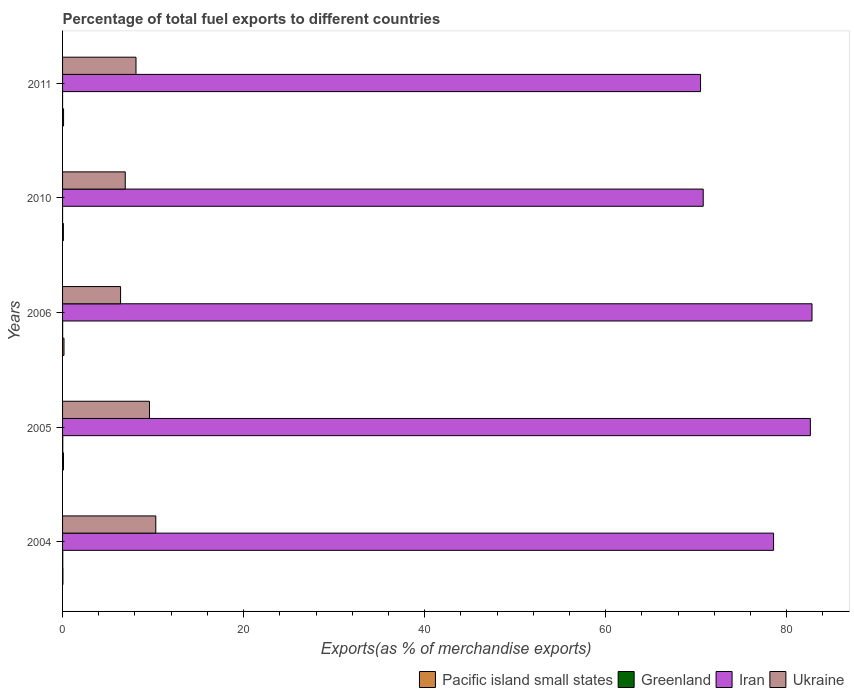How many different coloured bars are there?
Provide a short and direct response. 4. How many groups of bars are there?
Provide a succinct answer. 5. Are the number of bars per tick equal to the number of legend labels?
Offer a terse response. Yes. Are the number of bars on each tick of the Y-axis equal?
Your answer should be very brief. Yes. How many bars are there on the 1st tick from the top?
Offer a terse response. 4. How many bars are there on the 5th tick from the bottom?
Keep it short and to the point. 4. What is the percentage of exports to different countries in Greenland in 2005?
Keep it short and to the point. 0.02. Across all years, what is the maximum percentage of exports to different countries in Iran?
Keep it short and to the point. 82.79. Across all years, what is the minimum percentage of exports to different countries in Iran?
Offer a terse response. 70.48. In which year was the percentage of exports to different countries in Ukraine maximum?
Your answer should be compact. 2004. What is the total percentage of exports to different countries in Iran in the graph?
Provide a short and direct response. 385.2. What is the difference between the percentage of exports to different countries in Iran in 2006 and that in 2011?
Provide a short and direct response. 12.31. What is the difference between the percentage of exports to different countries in Pacific island small states in 2006 and the percentage of exports to different countries in Ukraine in 2005?
Make the answer very short. -9.44. What is the average percentage of exports to different countries in Pacific island small states per year?
Your answer should be compact. 0.1. In the year 2005, what is the difference between the percentage of exports to different countries in Pacific island small states and percentage of exports to different countries in Iran?
Keep it short and to the point. -82.51. What is the ratio of the percentage of exports to different countries in Iran in 2005 to that in 2010?
Ensure brevity in your answer.  1.17. Is the percentage of exports to different countries in Greenland in 2005 less than that in 2011?
Give a very brief answer. No. Is the difference between the percentage of exports to different countries in Pacific island small states in 2006 and 2011 greater than the difference between the percentage of exports to different countries in Iran in 2006 and 2011?
Make the answer very short. No. What is the difference between the highest and the second highest percentage of exports to different countries in Ukraine?
Give a very brief answer. 0.7. What is the difference between the highest and the lowest percentage of exports to different countries in Ukraine?
Your answer should be very brief. 3.89. In how many years, is the percentage of exports to different countries in Greenland greater than the average percentage of exports to different countries in Greenland taken over all years?
Offer a very short reply. 2. Is it the case that in every year, the sum of the percentage of exports to different countries in Ukraine and percentage of exports to different countries in Greenland is greater than the sum of percentage of exports to different countries in Pacific island small states and percentage of exports to different countries in Iran?
Offer a very short reply. No. What does the 3rd bar from the top in 2006 represents?
Provide a short and direct response. Greenland. What does the 2nd bar from the bottom in 2004 represents?
Keep it short and to the point. Greenland. Is it the case that in every year, the sum of the percentage of exports to different countries in Pacific island small states and percentage of exports to different countries in Iran is greater than the percentage of exports to different countries in Greenland?
Provide a short and direct response. Yes. How many bars are there?
Provide a short and direct response. 20. Are all the bars in the graph horizontal?
Ensure brevity in your answer.  Yes. How many years are there in the graph?
Provide a short and direct response. 5. Does the graph contain any zero values?
Your response must be concise. No. Does the graph contain grids?
Ensure brevity in your answer.  No. Where does the legend appear in the graph?
Provide a short and direct response. Bottom right. How many legend labels are there?
Provide a short and direct response. 4. What is the title of the graph?
Offer a terse response. Percentage of total fuel exports to different countries. What is the label or title of the X-axis?
Offer a very short reply. Exports(as % of merchandise exports). What is the label or title of the Y-axis?
Keep it short and to the point. Years. What is the Exports(as % of merchandise exports) in Pacific island small states in 2004?
Ensure brevity in your answer.  0.04. What is the Exports(as % of merchandise exports) of Greenland in 2004?
Offer a very short reply. 0.02. What is the Exports(as % of merchandise exports) of Iran in 2004?
Give a very brief answer. 78.55. What is the Exports(as % of merchandise exports) of Ukraine in 2004?
Provide a short and direct response. 10.3. What is the Exports(as % of merchandise exports) in Pacific island small states in 2005?
Offer a terse response. 0.1. What is the Exports(as % of merchandise exports) of Greenland in 2005?
Your response must be concise. 0.02. What is the Exports(as % of merchandise exports) of Iran in 2005?
Your answer should be compact. 82.61. What is the Exports(as % of merchandise exports) of Ukraine in 2005?
Provide a succinct answer. 9.6. What is the Exports(as % of merchandise exports) in Pacific island small states in 2006?
Provide a succinct answer. 0.16. What is the Exports(as % of merchandise exports) in Greenland in 2006?
Your response must be concise. 0.01. What is the Exports(as % of merchandise exports) of Iran in 2006?
Provide a succinct answer. 82.79. What is the Exports(as % of merchandise exports) in Ukraine in 2006?
Offer a very short reply. 6.41. What is the Exports(as % of merchandise exports) of Pacific island small states in 2010?
Your response must be concise. 0.09. What is the Exports(as % of merchandise exports) in Greenland in 2010?
Provide a succinct answer. 0. What is the Exports(as % of merchandise exports) in Iran in 2010?
Your answer should be compact. 70.77. What is the Exports(as % of merchandise exports) in Ukraine in 2010?
Give a very brief answer. 6.93. What is the Exports(as % of merchandise exports) in Pacific island small states in 2011?
Your response must be concise. 0.11. What is the Exports(as % of merchandise exports) of Greenland in 2011?
Your response must be concise. 0. What is the Exports(as % of merchandise exports) of Iran in 2011?
Give a very brief answer. 70.48. What is the Exports(as % of merchandise exports) in Ukraine in 2011?
Your answer should be compact. 8.11. Across all years, what is the maximum Exports(as % of merchandise exports) of Pacific island small states?
Give a very brief answer. 0.16. Across all years, what is the maximum Exports(as % of merchandise exports) in Greenland?
Offer a very short reply. 0.02. Across all years, what is the maximum Exports(as % of merchandise exports) of Iran?
Give a very brief answer. 82.79. Across all years, what is the maximum Exports(as % of merchandise exports) of Ukraine?
Your answer should be very brief. 10.3. Across all years, what is the minimum Exports(as % of merchandise exports) in Pacific island small states?
Your answer should be compact. 0.04. Across all years, what is the minimum Exports(as % of merchandise exports) in Greenland?
Your response must be concise. 0. Across all years, what is the minimum Exports(as % of merchandise exports) of Iran?
Offer a terse response. 70.48. Across all years, what is the minimum Exports(as % of merchandise exports) in Ukraine?
Your answer should be very brief. 6.41. What is the total Exports(as % of merchandise exports) of Pacific island small states in the graph?
Offer a very short reply. 0.5. What is the total Exports(as % of merchandise exports) of Greenland in the graph?
Your answer should be very brief. 0.05. What is the total Exports(as % of merchandise exports) in Iran in the graph?
Provide a short and direct response. 385.2. What is the total Exports(as % of merchandise exports) in Ukraine in the graph?
Provide a succinct answer. 41.35. What is the difference between the Exports(as % of merchandise exports) in Pacific island small states in 2004 and that in 2005?
Make the answer very short. -0.06. What is the difference between the Exports(as % of merchandise exports) in Iran in 2004 and that in 2005?
Provide a short and direct response. -4.06. What is the difference between the Exports(as % of merchandise exports) in Ukraine in 2004 and that in 2005?
Give a very brief answer. 0.7. What is the difference between the Exports(as % of merchandise exports) in Pacific island small states in 2004 and that in 2006?
Make the answer very short. -0.12. What is the difference between the Exports(as % of merchandise exports) in Greenland in 2004 and that in 2006?
Ensure brevity in your answer.  0.01. What is the difference between the Exports(as % of merchandise exports) in Iran in 2004 and that in 2006?
Your answer should be very brief. -4.25. What is the difference between the Exports(as % of merchandise exports) of Ukraine in 2004 and that in 2006?
Offer a terse response. 3.89. What is the difference between the Exports(as % of merchandise exports) of Pacific island small states in 2004 and that in 2010?
Keep it short and to the point. -0.05. What is the difference between the Exports(as % of merchandise exports) in Greenland in 2004 and that in 2010?
Keep it short and to the point. 0.02. What is the difference between the Exports(as % of merchandise exports) in Iran in 2004 and that in 2010?
Provide a short and direct response. 7.77. What is the difference between the Exports(as % of merchandise exports) in Ukraine in 2004 and that in 2010?
Ensure brevity in your answer.  3.37. What is the difference between the Exports(as % of merchandise exports) in Pacific island small states in 2004 and that in 2011?
Your answer should be compact. -0.07. What is the difference between the Exports(as % of merchandise exports) in Greenland in 2004 and that in 2011?
Your answer should be compact. 0.02. What is the difference between the Exports(as % of merchandise exports) of Iran in 2004 and that in 2011?
Give a very brief answer. 8.07. What is the difference between the Exports(as % of merchandise exports) of Ukraine in 2004 and that in 2011?
Offer a terse response. 2.19. What is the difference between the Exports(as % of merchandise exports) of Pacific island small states in 2005 and that in 2006?
Provide a succinct answer. -0.05. What is the difference between the Exports(as % of merchandise exports) of Greenland in 2005 and that in 2006?
Give a very brief answer. 0.01. What is the difference between the Exports(as % of merchandise exports) in Iran in 2005 and that in 2006?
Ensure brevity in your answer.  -0.18. What is the difference between the Exports(as % of merchandise exports) in Ukraine in 2005 and that in 2006?
Offer a terse response. 3.19. What is the difference between the Exports(as % of merchandise exports) in Pacific island small states in 2005 and that in 2010?
Provide a short and direct response. 0.01. What is the difference between the Exports(as % of merchandise exports) of Greenland in 2005 and that in 2010?
Your answer should be compact. 0.02. What is the difference between the Exports(as % of merchandise exports) in Iran in 2005 and that in 2010?
Offer a very short reply. 11.84. What is the difference between the Exports(as % of merchandise exports) of Ukraine in 2005 and that in 2010?
Provide a succinct answer. 2.67. What is the difference between the Exports(as % of merchandise exports) in Pacific island small states in 2005 and that in 2011?
Ensure brevity in your answer.  -0.01. What is the difference between the Exports(as % of merchandise exports) in Greenland in 2005 and that in 2011?
Make the answer very short. 0.02. What is the difference between the Exports(as % of merchandise exports) in Iran in 2005 and that in 2011?
Ensure brevity in your answer.  12.13. What is the difference between the Exports(as % of merchandise exports) in Ukraine in 2005 and that in 2011?
Keep it short and to the point. 1.49. What is the difference between the Exports(as % of merchandise exports) of Pacific island small states in 2006 and that in 2010?
Provide a short and direct response. 0.07. What is the difference between the Exports(as % of merchandise exports) of Greenland in 2006 and that in 2010?
Provide a succinct answer. 0.01. What is the difference between the Exports(as % of merchandise exports) in Iran in 2006 and that in 2010?
Keep it short and to the point. 12.02. What is the difference between the Exports(as % of merchandise exports) in Ukraine in 2006 and that in 2010?
Your response must be concise. -0.52. What is the difference between the Exports(as % of merchandise exports) of Pacific island small states in 2006 and that in 2011?
Your response must be concise. 0.05. What is the difference between the Exports(as % of merchandise exports) in Greenland in 2006 and that in 2011?
Give a very brief answer. 0.01. What is the difference between the Exports(as % of merchandise exports) in Iran in 2006 and that in 2011?
Offer a terse response. 12.31. What is the difference between the Exports(as % of merchandise exports) in Ukraine in 2006 and that in 2011?
Keep it short and to the point. -1.7. What is the difference between the Exports(as % of merchandise exports) in Pacific island small states in 2010 and that in 2011?
Provide a short and direct response. -0.02. What is the difference between the Exports(as % of merchandise exports) in Greenland in 2010 and that in 2011?
Your response must be concise. 0. What is the difference between the Exports(as % of merchandise exports) of Iran in 2010 and that in 2011?
Make the answer very short. 0.3. What is the difference between the Exports(as % of merchandise exports) in Ukraine in 2010 and that in 2011?
Ensure brevity in your answer.  -1.19. What is the difference between the Exports(as % of merchandise exports) of Pacific island small states in 2004 and the Exports(as % of merchandise exports) of Greenland in 2005?
Your response must be concise. 0.02. What is the difference between the Exports(as % of merchandise exports) of Pacific island small states in 2004 and the Exports(as % of merchandise exports) of Iran in 2005?
Make the answer very short. -82.57. What is the difference between the Exports(as % of merchandise exports) in Pacific island small states in 2004 and the Exports(as % of merchandise exports) in Ukraine in 2005?
Ensure brevity in your answer.  -9.56. What is the difference between the Exports(as % of merchandise exports) of Greenland in 2004 and the Exports(as % of merchandise exports) of Iran in 2005?
Keep it short and to the point. -82.59. What is the difference between the Exports(as % of merchandise exports) of Greenland in 2004 and the Exports(as % of merchandise exports) of Ukraine in 2005?
Provide a short and direct response. -9.58. What is the difference between the Exports(as % of merchandise exports) of Iran in 2004 and the Exports(as % of merchandise exports) of Ukraine in 2005?
Keep it short and to the point. 68.95. What is the difference between the Exports(as % of merchandise exports) in Pacific island small states in 2004 and the Exports(as % of merchandise exports) in Greenland in 2006?
Ensure brevity in your answer.  0.03. What is the difference between the Exports(as % of merchandise exports) of Pacific island small states in 2004 and the Exports(as % of merchandise exports) of Iran in 2006?
Your response must be concise. -82.75. What is the difference between the Exports(as % of merchandise exports) in Pacific island small states in 2004 and the Exports(as % of merchandise exports) in Ukraine in 2006?
Your response must be concise. -6.37. What is the difference between the Exports(as % of merchandise exports) of Greenland in 2004 and the Exports(as % of merchandise exports) of Iran in 2006?
Provide a succinct answer. -82.77. What is the difference between the Exports(as % of merchandise exports) in Greenland in 2004 and the Exports(as % of merchandise exports) in Ukraine in 2006?
Make the answer very short. -6.39. What is the difference between the Exports(as % of merchandise exports) of Iran in 2004 and the Exports(as % of merchandise exports) of Ukraine in 2006?
Your response must be concise. 72.14. What is the difference between the Exports(as % of merchandise exports) in Pacific island small states in 2004 and the Exports(as % of merchandise exports) in Greenland in 2010?
Offer a terse response. 0.04. What is the difference between the Exports(as % of merchandise exports) of Pacific island small states in 2004 and the Exports(as % of merchandise exports) of Iran in 2010?
Ensure brevity in your answer.  -70.74. What is the difference between the Exports(as % of merchandise exports) of Pacific island small states in 2004 and the Exports(as % of merchandise exports) of Ukraine in 2010?
Provide a short and direct response. -6.89. What is the difference between the Exports(as % of merchandise exports) of Greenland in 2004 and the Exports(as % of merchandise exports) of Iran in 2010?
Ensure brevity in your answer.  -70.75. What is the difference between the Exports(as % of merchandise exports) in Greenland in 2004 and the Exports(as % of merchandise exports) in Ukraine in 2010?
Your response must be concise. -6.9. What is the difference between the Exports(as % of merchandise exports) in Iran in 2004 and the Exports(as % of merchandise exports) in Ukraine in 2010?
Ensure brevity in your answer.  71.62. What is the difference between the Exports(as % of merchandise exports) of Pacific island small states in 2004 and the Exports(as % of merchandise exports) of Greenland in 2011?
Offer a terse response. 0.04. What is the difference between the Exports(as % of merchandise exports) of Pacific island small states in 2004 and the Exports(as % of merchandise exports) of Iran in 2011?
Offer a terse response. -70.44. What is the difference between the Exports(as % of merchandise exports) in Pacific island small states in 2004 and the Exports(as % of merchandise exports) in Ukraine in 2011?
Make the answer very short. -8.07. What is the difference between the Exports(as % of merchandise exports) of Greenland in 2004 and the Exports(as % of merchandise exports) of Iran in 2011?
Make the answer very short. -70.46. What is the difference between the Exports(as % of merchandise exports) of Greenland in 2004 and the Exports(as % of merchandise exports) of Ukraine in 2011?
Ensure brevity in your answer.  -8.09. What is the difference between the Exports(as % of merchandise exports) in Iran in 2004 and the Exports(as % of merchandise exports) in Ukraine in 2011?
Offer a terse response. 70.43. What is the difference between the Exports(as % of merchandise exports) in Pacific island small states in 2005 and the Exports(as % of merchandise exports) in Greenland in 2006?
Offer a terse response. 0.09. What is the difference between the Exports(as % of merchandise exports) of Pacific island small states in 2005 and the Exports(as % of merchandise exports) of Iran in 2006?
Provide a short and direct response. -82.69. What is the difference between the Exports(as % of merchandise exports) of Pacific island small states in 2005 and the Exports(as % of merchandise exports) of Ukraine in 2006?
Offer a terse response. -6.31. What is the difference between the Exports(as % of merchandise exports) of Greenland in 2005 and the Exports(as % of merchandise exports) of Iran in 2006?
Make the answer very short. -82.77. What is the difference between the Exports(as % of merchandise exports) of Greenland in 2005 and the Exports(as % of merchandise exports) of Ukraine in 2006?
Your response must be concise. -6.39. What is the difference between the Exports(as % of merchandise exports) of Iran in 2005 and the Exports(as % of merchandise exports) of Ukraine in 2006?
Give a very brief answer. 76.2. What is the difference between the Exports(as % of merchandise exports) of Pacific island small states in 2005 and the Exports(as % of merchandise exports) of Greenland in 2010?
Keep it short and to the point. 0.1. What is the difference between the Exports(as % of merchandise exports) in Pacific island small states in 2005 and the Exports(as % of merchandise exports) in Iran in 2010?
Provide a short and direct response. -70.67. What is the difference between the Exports(as % of merchandise exports) of Pacific island small states in 2005 and the Exports(as % of merchandise exports) of Ukraine in 2010?
Your response must be concise. -6.82. What is the difference between the Exports(as % of merchandise exports) in Greenland in 2005 and the Exports(as % of merchandise exports) in Iran in 2010?
Make the answer very short. -70.75. What is the difference between the Exports(as % of merchandise exports) of Greenland in 2005 and the Exports(as % of merchandise exports) of Ukraine in 2010?
Your response must be concise. -6.9. What is the difference between the Exports(as % of merchandise exports) in Iran in 2005 and the Exports(as % of merchandise exports) in Ukraine in 2010?
Your answer should be compact. 75.69. What is the difference between the Exports(as % of merchandise exports) of Pacific island small states in 2005 and the Exports(as % of merchandise exports) of Greenland in 2011?
Ensure brevity in your answer.  0.1. What is the difference between the Exports(as % of merchandise exports) of Pacific island small states in 2005 and the Exports(as % of merchandise exports) of Iran in 2011?
Offer a terse response. -70.38. What is the difference between the Exports(as % of merchandise exports) of Pacific island small states in 2005 and the Exports(as % of merchandise exports) of Ukraine in 2011?
Give a very brief answer. -8.01. What is the difference between the Exports(as % of merchandise exports) in Greenland in 2005 and the Exports(as % of merchandise exports) in Iran in 2011?
Offer a terse response. -70.46. What is the difference between the Exports(as % of merchandise exports) of Greenland in 2005 and the Exports(as % of merchandise exports) of Ukraine in 2011?
Make the answer very short. -8.09. What is the difference between the Exports(as % of merchandise exports) of Iran in 2005 and the Exports(as % of merchandise exports) of Ukraine in 2011?
Keep it short and to the point. 74.5. What is the difference between the Exports(as % of merchandise exports) in Pacific island small states in 2006 and the Exports(as % of merchandise exports) in Greenland in 2010?
Make the answer very short. 0.16. What is the difference between the Exports(as % of merchandise exports) in Pacific island small states in 2006 and the Exports(as % of merchandise exports) in Iran in 2010?
Your response must be concise. -70.62. What is the difference between the Exports(as % of merchandise exports) in Pacific island small states in 2006 and the Exports(as % of merchandise exports) in Ukraine in 2010?
Provide a succinct answer. -6.77. What is the difference between the Exports(as % of merchandise exports) of Greenland in 2006 and the Exports(as % of merchandise exports) of Iran in 2010?
Provide a succinct answer. -70.77. What is the difference between the Exports(as % of merchandise exports) in Greenland in 2006 and the Exports(as % of merchandise exports) in Ukraine in 2010?
Keep it short and to the point. -6.92. What is the difference between the Exports(as % of merchandise exports) of Iran in 2006 and the Exports(as % of merchandise exports) of Ukraine in 2010?
Ensure brevity in your answer.  75.87. What is the difference between the Exports(as % of merchandise exports) in Pacific island small states in 2006 and the Exports(as % of merchandise exports) in Greenland in 2011?
Provide a succinct answer. 0.16. What is the difference between the Exports(as % of merchandise exports) in Pacific island small states in 2006 and the Exports(as % of merchandise exports) in Iran in 2011?
Provide a short and direct response. -70.32. What is the difference between the Exports(as % of merchandise exports) in Pacific island small states in 2006 and the Exports(as % of merchandise exports) in Ukraine in 2011?
Offer a very short reply. -7.96. What is the difference between the Exports(as % of merchandise exports) in Greenland in 2006 and the Exports(as % of merchandise exports) in Iran in 2011?
Ensure brevity in your answer.  -70.47. What is the difference between the Exports(as % of merchandise exports) of Greenland in 2006 and the Exports(as % of merchandise exports) of Ukraine in 2011?
Offer a terse response. -8.1. What is the difference between the Exports(as % of merchandise exports) of Iran in 2006 and the Exports(as % of merchandise exports) of Ukraine in 2011?
Keep it short and to the point. 74.68. What is the difference between the Exports(as % of merchandise exports) of Pacific island small states in 2010 and the Exports(as % of merchandise exports) of Greenland in 2011?
Offer a very short reply. 0.09. What is the difference between the Exports(as % of merchandise exports) in Pacific island small states in 2010 and the Exports(as % of merchandise exports) in Iran in 2011?
Make the answer very short. -70.39. What is the difference between the Exports(as % of merchandise exports) in Pacific island small states in 2010 and the Exports(as % of merchandise exports) in Ukraine in 2011?
Your answer should be very brief. -8.02. What is the difference between the Exports(as % of merchandise exports) in Greenland in 2010 and the Exports(as % of merchandise exports) in Iran in 2011?
Give a very brief answer. -70.48. What is the difference between the Exports(as % of merchandise exports) of Greenland in 2010 and the Exports(as % of merchandise exports) of Ukraine in 2011?
Make the answer very short. -8.11. What is the difference between the Exports(as % of merchandise exports) of Iran in 2010 and the Exports(as % of merchandise exports) of Ukraine in 2011?
Ensure brevity in your answer.  62.66. What is the average Exports(as % of merchandise exports) of Pacific island small states per year?
Ensure brevity in your answer.  0.1. What is the average Exports(as % of merchandise exports) in Greenland per year?
Make the answer very short. 0.01. What is the average Exports(as % of merchandise exports) of Iran per year?
Offer a very short reply. 77.04. What is the average Exports(as % of merchandise exports) of Ukraine per year?
Ensure brevity in your answer.  8.27. In the year 2004, what is the difference between the Exports(as % of merchandise exports) of Pacific island small states and Exports(as % of merchandise exports) of Greenland?
Offer a terse response. 0.02. In the year 2004, what is the difference between the Exports(as % of merchandise exports) of Pacific island small states and Exports(as % of merchandise exports) of Iran?
Give a very brief answer. -78.51. In the year 2004, what is the difference between the Exports(as % of merchandise exports) in Pacific island small states and Exports(as % of merchandise exports) in Ukraine?
Make the answer very short. -10.26. In the year 2004, what is the difference between the Exports(as % of merchandise exports) of Greenland and Exports(as % of merchandise exports) of Iran?
Your answer should be compact. -78.52. In the year 2004, what is the difference between the Exports(as % of merchandise exports) of Greenland and Exports(as % of merchandise exports) of Ukraine?
Offer a terse response. -10.28. In the year 2004, what is the difference between the Exports(as % of merchandise exports) of Iran and Exports(as % of merchandise exports) of Ukraine?
Give a very brief answer. 68.25. In the year 2005, what is the difference between the Exports(as % of merchandise exports) in Pacific island small states and Exports(as % of merchandise exports) in Greenland?
Provide a succinct answer. 0.08. In the year 2005, what is the difference between the Exports(as % of merchandise exports) in Pacific island small states and Exports(as % of merchandise exports) in Iran?
Ensure brevity in your answer.  -82.51. In the year 2005, what is the difference between the Exports(as % of merchandise exports) of Pacific island small states and Exports(as % of merchandise exports) of Ukraine?
Keep it short and to the point. -9.5. In the year 2005, what is the difference between the Exports(as % of merchandise exports) in Greenland and Exports(as % of merchandise exports) in Iran?
Provide a succinct answer. -82.59. In the year 2005, what is the difference between the Exports(as % of merchandise exports) in Greenland and Exports(as % of merchandise exports) in Ukraine?
Provide a succinct answer. -9.58. In the year 2005, what is the difference between the Exports(as % of merchandise exports) of Iran and Exports(as % of merchandise exports) of Ukraine?
Your response must be concise. 73.01. In the year 2006, what is the difference between the Exports(as % of merchandise exports) of Pacific island small states and Exports(as % of merchandise exports) of Greenland?
Keep it short and to the point. 0.15. In the year 2006, what is the difference between the Exports(as % of merchandise exports) of Pacific island small states and Exports(as % of merchandise exports) of Iran?
Your answer should be very brief. -82.64. In the year 2006, what is the difference between the Exports(as % of merchandise exports) in Pacific island small states and Exports(as % of merchandise exports) in Ukraine?
Ensure brevity in your answer.  -6.25. In the year 2006, what is the difference between the Exports(as % of merchandise exports) in Greenland and Exports(as % of merchandise exports) in Iran?
Provide a succinct answer. -82.79. In the year 2006, what is the difference between the Exports(as % of merchandise exports) in Greenland and Exports(as % of merchandise exports) in Ukraine?
Ensure brevity in your answer.  -6.4. In the year 2006, what is the difference between the Exports(as % of merchandise exports) of Iran and Exports(as % of merchandise exports) of Ukraine?
Offer a very short reply. 76.38. In the year 2010, what is the difference between the Exports(as % of merchandise exports) of Pacific island small states and Exports(as % of merchandise exports) of Greenland?
Offer a very short reply. 0.09. In the year 2010, what is the difference between the Exports(as % of merchandise exports) in Pacific island small states and Exports(as % of merchandise exports) in Iran?
Keep it short and to the point. -70.68. In the year 2010, what is the difference between the Exports(as % of merchandise exports) in Pacific island small states and Exports(as % of merchandise exports) in Ukraine?
Offer a terse response. -6.84. In the year 2010, what is the difference between the Exports(as % of merchandise exports) of Greenland and Exports(as % of merchandise exports) of Iran?
Provide a succinct answer. -70.77. In the year 2010, what is the difference between the Exports(as % of merchandise exports) of Greenland and Exports(as % of merchandise exports) of Ukraine?
Ensure brevity in your answer.  -6.92. In the year 2010, what is the difference between the Exports(as % of merchandise exports) in Iran and Exports(as % of merchandise exports) in Ukraine?
Make the answer very short. 63.85. In the year 2011, what is the difference between the Exports(as % of merchandise exports) of Pacific island small states and Exports(as % of merchandise exports) of Greenland?
Your answer should be very brief. 0.11. In the year 2011, what is the difference between the Exports(as % of merchandise exports) of Pacific island small states and Exports(as % of merchandise exports) of Iran?
Ensure brevity in your answer.  -70.37. In the year 2011, what is the difference between the Exports(as % of merchandise exports) of Pacific island small states and Exports(as % of merchandise exports) of Ukraine?
Make the answer very short. -8. In the year 2011, what is the difference between the Exports(as % of merchandise exports) of Greenland and Exports(as % of merchandise exports) of Iran?
Offer a terse response. -70.48. In the year 2011, what is the difference between the Exports(as % of merchandise exports) of Greenland and Exports(as % of merchandise exports) of Ukraine?
Provide a succinct answer. -8.11. In the year 2011, what is the difference between the Exports(as % of merchandise exports) of Iran and Exports(as % of merchandise exports) of Ukraine?
Give a very brief answer. 62.37. What is the ratio of the Exports(as % of merchandise exports) of Pacific island small states in 2004 to that in 2005?
Keep it short and to the point. 0.39. What is the ratio of the Exports(as % of merchandise exports) in Greenland in 2004 to that in 2005?
Give a very brief answer. 1.02. What is the ratio of the Exports(as % of merchandise exports) of Iran in 2004 to that in 2005?
Make the answer very short. 0.95. What is the ratio of the Exports(as % of merchandise exports) in Ukraine in 2004 to that in 2005?
Offer a terse response. 1.07. What is the ratio of the Exports(as % of merchandise exports) in Pacific island small states in 2004 to that in 2006?
Your response must be concise. 0.25. What is the ratio of the Exports(as % of merchandise exports) of Greenland in 2004 to that in 2006?
Provide a succinct answer. 2.93. What is the ratio of the Exports(as % of merchandise exports) in Iran in 2004 to that in 2006?
Offer a terse response. 0.95. What is the ratio of the Exports(as % of merchandise exports) in Ukraine in 2004 to that in 2006?
Offer a terse response. 1.61. What is the ratio of the Exports(as % of merchandise exports) in Pacific island small states in 2004 to that in 2010?
Keep it short and to the point. 0.44. What is the ratio of the Exports(as % of merchandise exports) in Greenland in 2004 to that in 2010?
Your response must be concise. 48.47. What is the ratio of the Exports(as % of merchandise exports) in Iran in 2004 to that in 2010?
Provide a succinct answer. 1.11. What is the ratio of the Exports(as % of merchandise exports) of Ukraine in 2004 to that in 2010?
Keep it short and to the point. 1.49. What is the ratio of the Exports(as % of merchandise exports) in Pacific island small states in 2004 to that in 2011?
Provide a short and direct response. 0.36. What is the ratio of the Exports(as % of merchandise exports) in Greenland in 2004 to that in 2011?
Ensure brevity in your answer.  89.33. What is the ratio of the Exports(as % of merchandise exports) of Iran in 2004 to that in 2011?
Offer a terse response. 1.11. What is the ratio of the Exports(as % of merchandise exports) of Ukraine in 2004 to that in 2011?
Offer a very short reply. 1.27. What is the ratio of the Exports(as % of merchandise exports) of Pacific island small states in 2005 to that in 2006?
Make the answer very short. 0.65. What is the ratio of the Exports(as % of merchandise exports) of Greenland in 2005 to that in 2006?
Provide a short and direct response. 2.87. What is the ratio of the Exports(as % of merchandise exports) in Iran in 2005 to that in 2006?
Provide a succinct answer. 1. What is the ratio of the Exports(as % of merchandise exports) in Ukraine in 2005 to that in 2006?
Your response must be concise. 1.5. What is the ratio of the Exports(as % of merchandise exports) of Pacific island small states in 2005 to that in 2010?
Keep it short and to the point. 1.13. What is the ratio of the Exports(as % of merchandise exports) of Greenland in 2005 to that in 2010?
Give a very brief answer. 47.37. What is the ratio of the Exports(as % of merchandise exports) of Iran in 2005 to that in 2010?
Offer a terse response. 1.17. What is the ratio of the Exports(as % of merchandise exports) of Ukraine in 2005 to that in 2010?
Your answer should be very brief. 1.39. What is the ratio of the Exports(as % of merchandise exports) of Pacific island small states in 2005 to that in 2011?
Offer a terse response. 0.93. What is the ratio of the Exports(as % of merchandise exports) of Greenland in 2005 to that in 2011?
Your answer should be very brief. 87.3. What is the ratio of the Exports(as % of merchandise exports) of Iran in 2005 to that in 2011?
Provide a succinct answer. 1.17. What is the ratio of the Exports(as % of merchandise exports) in Ukraine in 2005 to that in 2011?
Your answer should be very brief. 1.18. What is the ratio of the Exports(as % of merchandise exports) of Pacific island small states in 2006 to that in 2010?
Make the answer very short. 1.73. What is the ratio of the Exports(as % of merchandise exports) of Greenland in 2006 to that in 2010?
Your response must be concise. 16.52. What is the ratio of the Exports(as % of merchandise exports) of Iran in 2006 to that in 2010?
Keep it short and to the point. 1.17. What is the ratio of the Exports(as % of merchandise exports) in Ukraine in 2006 to that in 2010?
Make the answer very short. 0.93. What is the ratio of the Exports(as % of merchandise exports) of Pacific island small states in 2006 to that in 2011?
Your response must be concise. 1.42. What is the ratio of the Exports(as % of merchandise exports) in Greenland in 2006 to that in 2011?
Your answer should be compact. 30.44. What is the ratio of the Exports(as % of merchandise exports) in Iran in 2006 to that in 2011?
Ensure brevity in your answer.  1.17. What is the ratio of the Exports(as % of merchandise exports) in Ukraine in 2006 to that in 2011?
Make the answer very short. 0.79. What is the ratio of the Exports(as % of merchandise exports) of Pacific island small states in 2010 to that in 2011?
Your response must be concise. 0.82. What is the ratio of the Exports(as % of merchandise exports) of Greenland in 2010 to that in 2011?
Your answer should be compact. 1.84. What is the ratio of the Exports(as % of merchandise exports) of Iran in 2010 to that in 2011?
Provide a succinct answer. 1. What is the ratio of the Exports(as % of merchandise exports) of Ukraine in 2010 to that in 2011?
Provide a short and direct response. 0.85. What is the difference between the highest and the second highest Exports(as % of merchandise exports) in Pacific island small states?
Offer a terse response. 0.05. What is the difference between the highest and the second highest Exports(as % of merchandise exports) of Iran?
Make the answer very short. 0.18. What is the difference between the highest and the second highest Exports(as % of merchandise exports) in Ukraine?
Make the answer very short. 0.7. What is the difference between the highest and the lowest Exports(as % of merchandise exports) of Pacific island small states?
Make the answer very short. 0.12. What is the difference between the highest and the lowest Exports(as % of merchandise exports) of Greenland?
Provide a short and direct response. 0.02. What is the difference between the highest and the lowest Exports(as % of merchandise exports) of Iran?
Keep it short and to the point. 12.31. What is the difference between the highest and the lowest Exports(as % of merchandise exports) of Ukraine?
Provide a short and direct response. 3.89. 